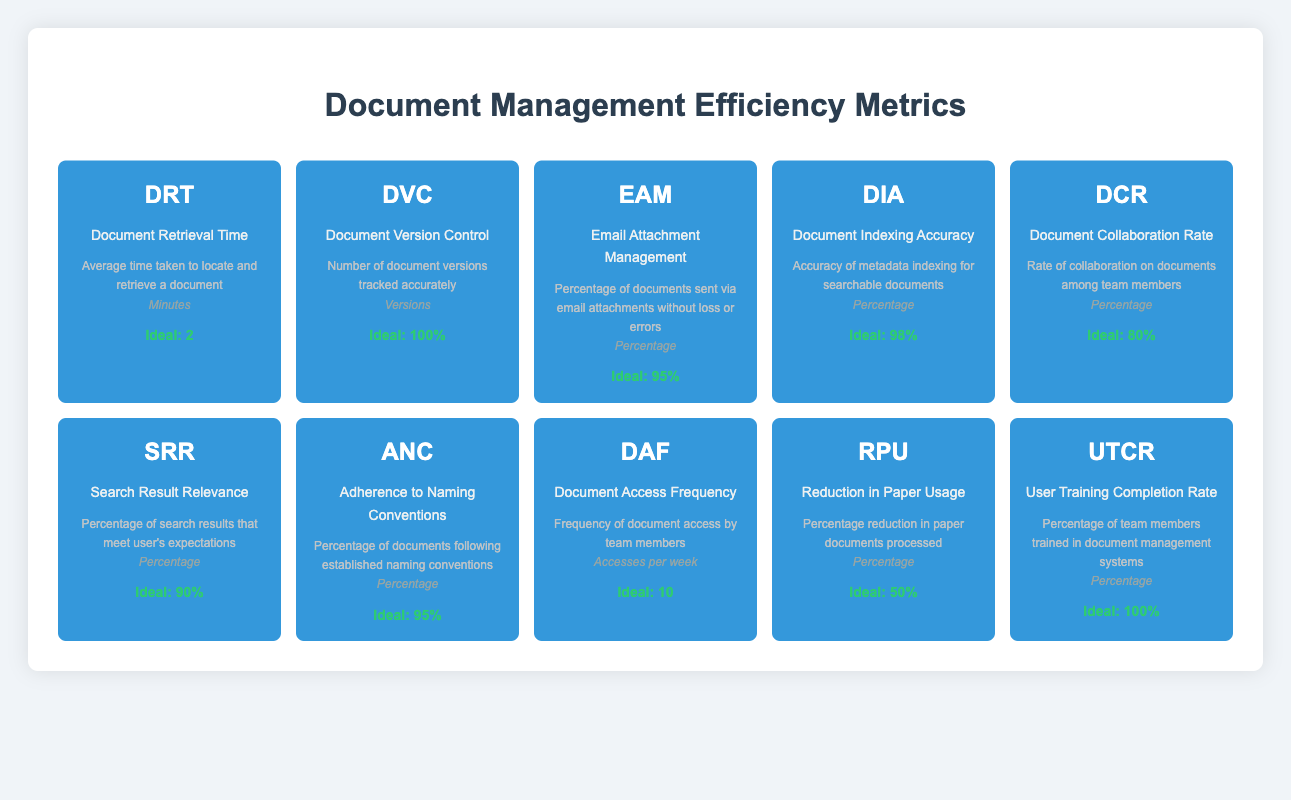What is the ideal value for Document Retrieval Time (DRT)? The ideal value for Document Retrieval Time (DRT) is listed in the table under the "Ideal Value" column next to DRT. It is stated as 2 minutes.
Answer: 2 minutes How many document versions should be tracked for Document Version Control (DVC)? The ideal value for Document Version Control (DVC) is found in the table under the "Ideal Value" column, where it indicates that 100% of document versions should be tracked accurately.
Answer: 100% Is the ideal value for Email Attachment Management (EAM) higher than that for Search Result Relevance (SRR)? The ideal value for Email Attachment Management (EAM) is 95%, while the ideal value for Search Result Relevance (SRR) is 90%. Since 95% is higher than 90%, the answer is yes.
Answer: Yes What is the cumulative ideal percentage of Adherence to Naming Conventions (ANC) and Document Collaboration Rate (DCR)? The ideal value for Adherence to Naming Conventions (ANC) is 95% and for Document Collaboration Rate (DCR) it is 80%. To find the cumulative ideal percentage, we add them together: 95% + 80% = 175%.
Answer: 175% Does the Document Access Frequency (DAF) ideal value meet or exceed 10 accesses per week? The ideal value for Document Access Frequency (DAF) is 10 accesses per week, therefore it meets this value as it is equal to 10.
Answer: Yes Which metric has the highest ideal percentage value? Reviewing the table, the ideal values indicate that Document Version Control (DVC) has the highest ideal value at 100%. It is necessary to compare all ideal percentage values listed in the table.
Answer: Document Version Control (DVC) What is the average ideal value of the Search Result Relevance (SRR) and Document Indexing Accuracy (DIA)? Search Result Relevance (SRR) has an ideal value of 90%, and Document Indexing Accuracy (DIA) has an ideal value of 98%. To find the average, we add the two ideal values together (90% + 98%) and divide by 2: (188% / 2) = 94%.
Answer: 94% Is the User Training Completion Rate (UTCR) equal to the ideal value of Document Version Control (DVC)? The ideal value of User Training Completion Rate (UTCR) is 100% and the ideal value of Document Version Control (DVC) is also 100%. Since both values are equal, the answer is yes.
Answer: Yes What is the difference between the ideal percentage for Reduction in Paper Usage (RPU) and Document Collaboration Rate (DCR)? The ideal value for Reduction in Paper Usage (RPU) is 50% and for Document Collaboration Rate (DCR) it is 80%. To find the difference, we subtract RPU from DCR: 80% - 50% = 30%.
Answer: 30% 